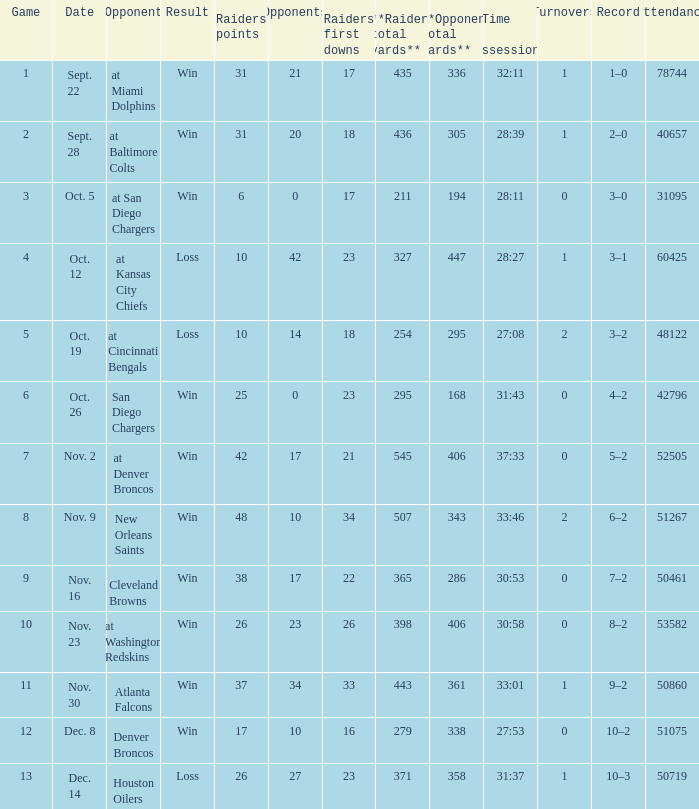What was the result of the game seen by 31095 people? Win. 